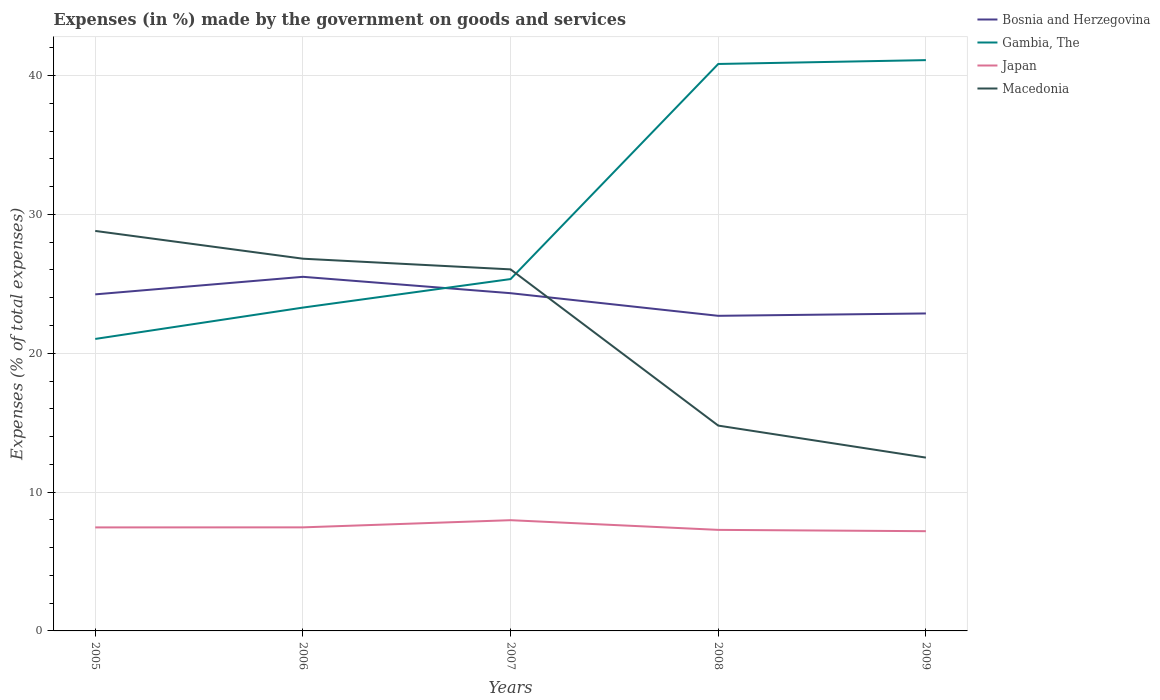Does the line corresponding to Macedonia intersect with the line corresponding to Bosnia and Herzegovina?
Offer a terse response. Yes. Across all years, what is the maximum percentage of expenses made by the government on goods and services in Japan?
Ensure brevity in your answer.  7.18. What is the total percentage of expenses made by the government on goods and services in Bosnia and Herzegovina in the graph?
Offer a very short reply. 1.18. What is the difference between the highest and the second highest percentage of expenses made by the government on goods and services in Japan?
Provide a succinct answer. 0.79. What is the difference between the highest and the lowest percentage of expenses made by the government on goods and services in Macedonia?
Give a very brief answer. 3. Is the percentage of expenses made by the government on goods and services in Japan strictly greater than the percentage of expenses made by the government on goods and services in Macedonia over the years?
Your answer should be very brief. Yes. How many years are there in the graph?
Ensure brevity in your answer.  5. What is the difference between two consecutive major ticks on the Y-axis?
Your answer should be compact. 10. Are the values on the major ticks of Y-axis written in scientific E-notation?
Your answer should be compact. No. Does the graph contain grids?
Provide a succinct answer. Yes. Where does the legend appear in the graph?
Offer a very short reply. Top right. What is the title of the graph?
Provide a succinct answer. Expenses (in %) made by the government on goods and services. Does "Armenia" appear as one of the legend labels in the graph?
Your answer should be very brief. No. What is the label or title of the Y-axis?
Provide a succinct answer. Expenses (% of total expenses). What is the Expenses (% of total expenses) in Bosnia and Herzegovina in 2005?
Offer a terse response. 24.24. What is the Expenses (% of total expenses) of Gambia, The in 2005?
Offer a terse response. 21.03. What is the Expenses (% of total expenses) in Japan in 2005?
Offer a very short reply. 7.46. What is the Expenses (% of total expenses) of Macedonia in 2005?
Offer a terse response. 28.81. What is the Expenses (% of total expenses) in Bosnia and Herzegovina in 2006?
Your response must be concise. 25.5. What is the Expenses (% of total expenses) of Gambia, The in 2006?
Offer a very short reply. 23.29. What is the Expenses (% of total expenses) of Japan in 2006?
Offer a terse response. 7.46. What is the Expenses (% of total expenses) in Macedonia in 2006?
Your response must be concise. 26.81. What is the Expenses (% of total expenses) in Bosnia and Herzegovina in 2007?
Make the answer very short. 24.32. What is the Expenses (% of total expenses) in Gambia, The in 2007?
Your response must be concise. 25.34. What is the Expenses (% of total expenses) of Japan in 2007?
Offer a terse response. 7.98. What is the Expenses (% of total expenses) in Macedonia in 2007?
Give a very brief answer. 26.04. What is the Expenses (% of total expenses) in Bosnia and Herzegovina in 2008?
Offer a very short reply. 22.7. What is the Expenses (% of total expenses) of Gambia, The in 2008?
Provide a short and direct response. 40.83. What is the Expenses (% of total expenses) of Japan in 2008?
Offer a very short reply. 7.28. What is the Expenses (% of total expenses) in Macedonia in 2008?
Your response must be concise. 14.79. What is the Expenses (% of total expenses) of Bosnia and Herzegovina in 2009?
Offer a terse response. 22.87. What is the Expenses (% of total expenses) of Gambia, The in 2009?
Your response must be concise. 41.11. What is the Expenses (% of total expenses) of Japan in 2009?
Your answer should be compact. 7.18. What is the Expenses (% of total expenses) in Macedonia in 2009?
Provide a succinct answer. 12.48. Across all years, what is the maximum Expenses (% of total expenses) in Bosnia and Herzegovina?
Offer a very short reply. 25.5. Across all years, what is the maximum Expenses (% of total expenses) in Gambia, The?
Provide a succinct answer. 41.11. Across all years, what is the maximum Expenses (% of total expenses) in Japan?
Your answer should be very brief. 7.98. Across all years, what is the maximum Expenses (% of total expenses) of Macedonia?
Provide a short and direct response. 28.81. Across all years, what is the minimum Expenses (% of total expenses) of Bosnia and Herzegovina?
Provide a succinct answer. 22.7. Across all years, what is the minimum Expenses (% of total expenses) in Gambia, The?
Provide a short and direct response. 21.03. Across all years, what is the minimum Expenses (% of total expenses) of Japan?
Your answer should be compact. 7.18. Across all years, what is the minimum Expenses (% of total expenses) in Macedonia?
Provide a short and direct response. 12.48. What is the total Expenses (% of total expenses) of Bosnia and Herzegovina in the graph?
Ensure brevity in your answer.  119.63. What is the total Expenses (% of total expenses) in Gambia, The in the graph?
Give a very brief answer. 151.6. What is the total Expenses (% of total expenses) in Japan in the graph?
Your response must be concise. 37.35. What is the total Expenses (% of total expenses) of Macedonia in the graph?
Offer a terse response. 108.93. What is the difference between the Expenses (% of total expenses) in Bosnia and Herzegovina in 2005 and that in 2006?
Offer a very short reply. -1.26. What is the difference between the Expenses (% of total expenses) of Gambia, The in 2005 and that in 2006?
Offer a terse response. -2.26. What is the difference between the Expenses (% of total expenses) in Japan in 2005 and that in 2006?
Offer a very short reply. -0. What is the difference between the Expenses (% of total expenses) of Macedonia in 2005 and that in 2006?
Keep it short and to the point. 2. What is the difference between the Expenses (% of total expenses) of Bosnia and Herzegovina in 2005 and that in 2007?
Your answer should be compact. -0.08. What is the difference between the Expenses (% of total expenses) in Gambia, The in 2005 and that in 2007?
Ensure brevity in your answer.  -4.31. What is the difference between the Expenses (% of total expenses) in Japan in 2005 and that in 2007?
Offer a very short reply. -0.52. What is the difference between the Expenses (% of total expenses) in Macedonia in 2005 and that in 2007?
Offer a terse response. 2.77. What is the difference between the Expenses (% of total expenses) in Bosnia and Herzegovina in 2005 and that in 2008?
Offer a very short reply. 1.54. What is the difference between the Expenses (% of total expenses) in Gambia, The in 2005 and that in 2008?
Offer a very short reply. -19.8. What is the difference between the Expenses (% of total expenses) in Japan in 2005 and that in 2008?
Keep it short and to the point. 0.18. What is the difference between the Expenses (% of total expenses) in Macedonia in 2005 and that in 2008?
Ensure brevity in your answer.  14.02. What is the difference between the Expenses (% of total expenses) in Bosnia and Herzegovina in 2005 and that in 2009?
Give a very brief answer. 1.37. What is the difference between the Expenses (% of total expenses) in Gambia, The in 2005 and that in 2009?
Offer a terse response. -20.08. What is the difference between the Expenses (% of total expenses) of Japan in 2005 and that in 2009?
Keep it short and to the point. 0.27. What is the difference between the Expenses (% of total expenses) of Macedonia in 2005 and that in 2009?
Your answer should be compact. 16.33. What is the difference between the Expenses (% of total expenses) in Bosnia and Herzegovina in 2006 and that in 2007?
Offer a terse response. 1.18. What is the difference between the Expenses (% of total expenses) in Gambia, The in 2006 and that in 2007?
Ensure brevity in your answer.  -2.05. What is the difference between the Expenses (% of total expenses) in Japan in 2006 and that in 2007?
Make the answer very short. -0.52. What is the difference between the Expenses (% of total expenses) in Macedonia in 2006 and that in 2007?
Offer a very short reply. 0.77. What is the difference between the Expenses (% of total expenses) of Bosnia and Herzegovina in 2006 and that in 2008?
Provide a short and direct response. 2.81. What is the difference between the Expenses (% of total expenses) of Gambia, The in 2006 and that in 2008?
Your answer should be very brief. -17.55. What is the difference between the Expenses (% of total expenses) in Japan in 2006 and that in 2008?
Give a very brief answer. 0.18. What is the difference between the Expenses (% of total expenses) of Macedonia in 2006 and that in 2008?
Your answer should be very brief. 12.02. What is the difference between the Expenses (% of total expenses) of Bosnia and Herzegovina in 2006 and that in 2009?
Ensure brevity in your answer.  2.64. What is the difference between the Expenses (% of total expenses) in Gambia, The in 2006 and that in 2009?
Your response must be concise. -17.82. What is the difference between the Expenses (% of total expenses) in Japan in 2006 and that in 2009?
Your answer should be compact. 0.28. What is the difference between the Expenses (% of total expenses) in Macedonia in 2006 and that in 2009?
Provide a succinct answer. 14.33. What is the difference between the Expenses (% of total expenses) in Bosnia and Herzegovina in 2007 and that in 2008?
Your answer should be very brief. 1.63. What is the difference between the Expenses (% of total expenses) in Gambia, The in 2007 and that in 2008?
Provide a succinct answer. -15.49. What is the difference between the Expenses (% of total expenses) in Japan in 2007 and that in 2008?
Provide a succinct answer. 0.7. What is the difference between the Expenses (% of total expenses) in Macedonia in 2007 and that in 2008?
Provide a short and direct response. 11.25. What is the difference between the Expenses (% of total expenses) of Bosnia and Herzegovina in 2007 and that in 2009?
Give a very brief answer. 1.46. What is the difference between the Expenses (% of total expenses) in Gambia, The in 2007 and that in 2009?
Provide a succinct answer. -15.77. What is the difference between the Expenses (% of total expenses) of Japan in 2007 and that in 2009?
Provide a succinct answer. 0.79. What is the difference between the Expenses (% of total expenses) of Macedonia in 2007 and that in 2009?
Provide a short and direct response. 13.56. What is the difference between the Expenses (% of total expenses) in Bosnia and Herzegovina in 2008 and that in 2009?
Your answer should be very brief. -0.17. What is the difference between the Expenses (% of total expenses) of Gambia, The in 2008 and that in 2009?
Keep it short and to the point. -0.28. What is the difference between the Expenses (% of total expenses) of Japan in 2008 and that in 2009?
Provide a succinct answer. 0.09. What is the difference between the Expenses (% of total expenses) of Macedonia in 2008 and that in 2009?
Make the answer very short. 2.31. What is the difference between the Expenses (% of total expenses) of Bosnia and Herzegovina in 2005 and the Expenses (% of total expenses) of Gambia, The in 2006?
Your answer should be compact. 0.95. What is the difference between the Expenses (% of total expenses) of Bosnia and Herzegovina in 2005 and the Expenses (% of total expenses) of Japan in 2006?
Ensure brevity in your answer.  16.78. What is the difference between the Expenses (% of total expenses) of Bosnia and Herzegovina in 2005 and the Expenses (% of total expenses) of Macedonia in 2006?
Give a very brief answer. -2.57. What is the difference between the Expenses (% of total expenses) in Gambia, The in 2005 and the Expenses (% of total expenses) in Japan in 2006?
Give a very brief answer. 13.57. What is the difference between the Expenses (% of total expenses) of Gambia, The in 2005 and the Expenses (% of total expenses) of Macedonia in 2006?
Your answer should be compact. -5.78. What is the difference between the Expenses (% of total expenses) in Japan in 2005 and the Expenses (% of total expenses) in Macedonia in 2006?
Keep it short and to the point. -19.35. What is the difference between the Expenses (% of total expenses) in Bosnia and Herzegovina in 2005 and the Expenses (% of total expenses) in Gambia, The in 2007?
Ensure brevity in your answer.  -1.1. What is the difference between the Expenses (% of total expenses) of Bosnia and Herzegovina in 2005 and the Expenses (% of total expenses) of Japan in 2007?
Your answer should be compact. 16.26. What is the difference between the Expenses (% of total expenses) in Bosnia and Herzegovina in 2005 and the Expenses (% of total expenses) in Macedonia in 2007?
Your answer should be compact. -1.8. What is the difference between the Expenses (% of total expenses) in Gambia, The in 2005 and the Expenses (% of total expenses) in Japan in 2007?
Provide a short and direct response. 13.05. What is the difference between the Expenses (% of total expenses) of Gambia, The in 2005 and the Expenses (% of total expenses) of Macedonia in 2007?
Your answer should be very brief. -5.01. What is the difference between the Expenses (% of total expenses) in Japan in 2005 and the Expenses (% of total expenses) in Macedonia in 2007?
Offer a very short reply. -18.58. What is the difference between the Expenses (% of total expenses) of Bosnia and Herzegovina in 2005 and the Expenses (% of total expenses) of Gambia, The in 2008?
Ensure brevity in your answer.  -16.59. What is the difference between the Expenses (% of total expenses) in Bosnia and Herzegovina in 2005 and the Expenses (% of total expenses) in Japan in 2008?
Give a very brief answer. 16.96. What is the difference between the Expenses (% of total expenses) of Bosnia and Herzegovina in 2005 and the Expenses (% of total expenses) of Macedonia in 2008?
Offer a terse response. 9.45. What is the difference between the Expenses (% of total expenses) of Gambia, The in 2005 and the Expenses (% of total expenses) of Japan in 2008?
Offer a terse response. 13.75. What is the difference between the Expenses (% of total expenses) of Gambia, The in 2005 and the Expenses (% of total expenses) of Macedonia in 2008?
Provide a short and direct response. 6.24. What is the difference between the Expenses (% of total expenses) in Japan in 2005 and the Expenses (% of total expenses) in Macedonia in 2008?
Offer a very short reply. -7.33. What is the difference between the Expenses (% of total expenses) in Bosnia and Herzegovina in 2005 and the Expenses (% of total expenses) in Gambia, The in 2009?
Keep it short and to the point. -16.87. What is the difference between the Expenses (% of total expenses) in Bosnia and Herzegovina in 2005 and the Expenses (% of total expenses) in Japan in 2009?
Offer a very short reply. 17.06. What is the difference between the Expenses (% of total expenses) in Bosnia and Herzegovina in 2005 and the Expenses (% of total expenses) in Macedonia in 2009?
Offer a very short reply. 11.76. What is the difference between the Expenses (% of total expenses) of Gambia, The in 2005 and the Expenses (% of total expenses) of Japan in 2009?
Make the answer very short. 13.85. What is the difference between the Expenses (% of total expenses) in Gambia, The in 2005 and the Expenses (% of total expenses) in Macedonia in 2009?
Your answer should be very brief. 8.55. What is the difference between the Expenses (% of total expenses) of Japan in 2005 and the Expenses (% of total expenses) of Macedonia in 2009?
Offer a very short reply. -5.03. What is the difference between the Expenses (% of total expenses) in Bosnia and Herzegovina in 2006 and the Expenses (% of total expenses) in Gambia, The in 2007?
Your answer should be compact. 0.16. What is the difference between the Expenses (% of total expenses) in Bosnia and Herzegovina in 2006 and the Expenses (% of total expenses) in Japan in 2007?
Ensure brevity in your answer.  17.53. What is the difference between the Expenses (% of total expenses) in Bosnia and Herzegovina in 2006 and the Expenses (% of total expenses) in Macedonia in 2007?
Ensure brevity in your answer.  -0.54. What is the difference between the Expenses (% of total expenses) of Gambia, The in 2006 and the Expenses (% of total expenses) of Japan in 2007?
Keep it short and to the point. 15.31. What is the difference between the Expenses (% of total expenses) in Gambia, The in 2006 and the Expenses (% of total expenses) in Macedonia in 2007?
Your response must be concise. -2.75. What is the difference between the Expenses (% of total expenses) in Japan in 2006 and the Expenses (% of total expenses) in Macedonia in 2007?
Offer a terse response. -18.58. What is the difference between the Expenses (% of total expenses) in Bosnia and Herzegovina in 2006 and the Expenses (% of total expenses) in Gambia, The in 2008?
Offer a terse response. -15.33. What is the difference between the Expenses (% of total expenses) in Bosnia and Herzegovina in 2006 and the Expenses (% of total expenses) in Japan in 2008?
Provide a succinct answer. 18.23. What is the difference between the Expenses (% of total expenses) of Bosnia and Herzegovina in 2006 and the Expenses (% of total expenses) of Macedonia in 2008?
Give a very brief answer. 10.72. What is the difference between the Expenses (% of total expenses) in Gambia, The in 2006 and the Expenses (% of total expenses) in Japan in 2008?
Your answer should be compact. 16.01. What is the difference between the Expenses (% of total expenses) in Gambia, The in 2006 and the Expenses (% of total expenses) in Macedonia in 2008?
Ensure brevity in your answer.  8.5. What is the difference between the Expenses (% of total expenses) of Japan in 2006 and the Expenses (% of total expenses) of Macedonia in 2008?
Make the answer very short. -7.33. What is the difference between the Expenses (% of total expenses) in Bosnia and Herzegovina in 2006 and the Expenses (% of total expenses) in Gambia, The in 2009?
Provide a succinct answer. -15.61. What is the difference between the Expenses (% of total expenses) of Bosnia and Herzegovina in 2006 and the Expenses (% of total expenses) of Japan in 2009?
Provide a succinct answer. 18.32. What is the difference between the Expenses (% of total expenses) of Bosnia and Herzegovina in 2006 and the Expenses (% of total expenses) of Macedonia in 2009?
Provide a succinct answer. 13.02. What is the difference between the Expenses (% of total expenses) of Gambia, The in 2006 and the Expenses (% of total expenses) of Japan in 2009?
Provide a short and direct response. 16.1. What is the difference between the Expenses (% of total expenses) of Gambia, The in 2006 and the Expenses (% of total expenses) of Macedonia in 2009?
Provide a short and direct response. 10.81. What is the difference between the Expenses (% of total expenses) of Japan in 2006 and the Expenses (% of total expenses) of Macedonia in 2009?
Provide a succinct answer. -5.02. What is the difference between the Expenses (% of total expenses) of Bosnia and Herzegovina in 2007 and the Expenses (% of total expenses) of Gambia, The in 2008?
Your response must be concise. -16.51. What is the difference between the Expenses (% of total expenses) of Bosnia and Herzegovina in 2007 and the Expenses (% of total expenses) of Japan in 2008?
Make the answer very short. 17.05. What is the difference between the Expenses (% of total expenses) of Bosnia and Herzegovina in 2007 and the Expenses (% of total expenses) of Macedonia in 2008?
Provide a short and direct response. 9.54. What is the difference between the Expenses (% of total expenses) of Gambia, The in 2007 and the Expenses (% of total expenses) of Japan in 2008?
Provide a succinct answer. 18.06. What is the difference between the Expenses (% of total expenses) of Gambia, The in 2007 and the Expenses (% of total expenses) of Macedonia in 2008?
Provide a short and direct response. 10.55. What is the difference between the Expenses (% of total expenses) in Japan in 2007 and the Expenses (% of total expenses) in Macedonia in 2008?
Keep it short and to the point. -6.81. What is the difference between the Expenses (% of total expenses) in Bosnia and Herzegovina in 2007 and the Expenses (% of total expenses) in Gambia, The in 2009?
Give a very brief answer. -16.79. What is the difference between the Expenses (% of total expenses) of Bosnia and Herzegovina in 2007 and the Expenses (% of total expenses) of Japan in 2009?
Your answer should be very brief. 17.14. What is the difference between the Expenses (% of total expenses) of Bosnia and Herzegovina in 2007 and the Expenses (% of total expenses) of Macedonia in 2009?
Make the answer very short. 11.84. What is the difference between the Expenses (% of total expenses) of Gambia, The in 2007 and the Expenses (% of total expenses) of Japan in 2009?
Offer a terse response. 18.16. What is the difference between the Expenses (% of total expenses) in Gambia, The in 2007 and the Expenses (% of total expenses) in Macedonia in 2009?
Provide a short and direct response. 12.86. What is the difference between the Expenses (% of total expenses) of Japan in 2007 and the Expenses (% of total expenses) of Macedonia in 2009?
Give a very brief answer. -4.51. What is the difference between the Expenses (% of total expenses) in Bosnia and Herzegovina in 2008 and the Expenses (% of total expenses) in Gambia, The in 2009?
Ensure brevity in your answer.  -18.42. What is the difference between the Expenses (% of total expenses) of Bosnia and Herzegovina in 2008 and the Expenses (% of total expenses) of Japan in 2009?
Your answer should be compact. 15.51. What is the difference between the Expenses (% of total expenses) of Bosnia and Herzegovina in 2008 and the Expenses (% of total expenses) of Macedonia in 2009?
Your response must be concise. 10.21. What is the difference between the Expenses (% of total expenses) in Gambia, The in 2008 and the Expenses (% of total expenses) in Japan in 2009?
Give a very brief answer. 33.65. What is the difference between the Expenses (% of total expenses) in Gambia, The in 2008 and the Expenses (% of total expenses) in Macedonia in 2009?
Make the answer very short. 28.35. What is the difference between the Expenses (% of total expenses) in Japan in 2008 and the Expenses (% of total expenses) in Macedonia in 2009?
Your answer should be compact. -5.2. What is the average Expenses (% of total expenses) of Bosnia and Herzegovina per year?
Make the answer very short. 23.93. What is the average Expenses (% of total expenses) of Gambia, The per year?
Offer a terse response. 30.32. What is the average Expenses (% of total expenses) in Japan per year?
Offer a terse response. 7.47. What is the average Expenses (% of total expenses) in Macedonia per year?
Keep it short and to the point. 21.79. In the year 2005, what is the difference between the Expenses (% of total expenses) in Bosnia and Herzegovina and Expenses (% of total expenses) in Gambia, The?
Your answer should be compact. 3.21. In the year 2005, what is the difference between the Expenses (% of total expenses) in Bosnia and Herzegovina and Expenses (% of total expenses) in Japan?
Provide a short and direct response. 16.78. In the year 2005, what is the difference between the Expenses (% of total expenses) in Bosnia and Herzegovina and Expenses (% of total expenses) in Macedonia?
Give a very brief answer. -4.57. In the year 2005, what is the difference between the Expenses (% of total expenses) of Gambia, The and Expenses (% of total expenses) of Japan?
Your response must be concise. 13.57. In the year 2005, what is the difference between the Expenses (% of total expenses) of Gambia, The and Expenses (% of total expenses) of Macedonia?
Make the answer very short. -7.78. In the year 2005, what is the difference between the Expenses (% of total expenses) of Japan and Expenses (% of total expenses) of Macedonia?
Keep it short and to the point. -21.35. In the year 2006, what is the difference between the Expenses (% of total expenses) of Bosnia and Herzegovina and Expenses (% of total expenses) of Gambia, The?
Provide a succinct answer. 2.22. In the year 2006, what is the difference between the Expenses (% of total expenses) in Bosnia and Herzegovina and Expenses (% of total expenses) in Japan?
Keep it short and to the point. 18.04. In the year 2006, what is the difference between the Expenses (% of total expenses) in Bosnia and Herzegovina and Expenses (% of total expenses) in Macedonia?
Ensure brevity in your answer.  -1.3. In the year 2006, what is the difference between the Expenses (% of total expenses) in Gambia, The and Expenses (% of total expenses) in Japan?
Your answer should be very brief. 15.83. In the year 2006, what is the difference between the Expenses (% of total expenses) of Gambia, The and Expenses (% of total expenses) of Macedonia?
Ensure brevity in your answer.  -3.52. In the year 2006, what is the difference between the Expenses (% of total expenses) of Japan and Expenses (% of total expenses) of Macedonia?
Offer a very short reply. -19.35. In the year 2007, what is the difference between the Expenses (% of total expenses) in Bosnia and Herzegovina and Expenses (% of total expenses) in Gambia, The?
Give a very brief answer. -1.02. In the year 2007, what is the difference between the Expenses (% of total expenses) of Bosnia and Herzegovina and Expenses (% of total expenses) of Japan?
Offer a very short reply. 16.35. In the year 2007, what is the difference between the Expenses (% of total expenses) of Bosnia and Herzegovina and Expenses (% of total expenses) of Macedonia?
Provide a short and direct response. -1.72. In the year 2007, what is the difference between the Expenses (% of total expenses) in Gambia, The and Expenses (% of total expenses) in Japan?
Offer a terse response. 17.37. In the year 2007, what is the difference between the Expenses (% of total expenses) of Gambia, The and Expenses (% of total expenses) of Macedonia?
Your answer should be compact. -0.7. In the year 2007, what is the difference between the Expenses (% of total expenses) in Japan and Expenses (% of total expenses) in Macedonia?
Provide a short and direct response. -18.06. In the year 2008, what is the difference between the Expenses (% of total expenses) in Bosnia and Herzegovina and Expenses (% of total expenses) in Gambia, The?
Keep it short and to the point. -18.14. In the year 2008, what is the difference between the Expenses (% of total expenses) of Bosnia and Herzegovina and Expenses (% of total expenses) of Japan?
Provide a short and direct response. 15.42. In the year 2008, what is the difference between the Expenses (% of total expenses) of Bosnia and Herzegovina and Expenses (% of total expenses) of Macedonia?
Provide a short and direct response. 7.91. In the year 2008, what is the difference between the Expenses (% of total expenses) in Gambia, The and Expenses (% of total expenses) in Japan?
Your response must be concise. 33.56. In the year 2008, what is the difference between the Expenses (% of total expenses) of Gambia, The and Expenses (% of total expenses) of Macedonia?
Offer a terse response. 26.04. In the year 2008, what is the difference between the Expenses (% of total expenses) of Japan and Expenses (% of total expenses) of Macedonia?
Ensure brevity in your answer.  -7.51. In the year 2009, what is the difference between the Expenses (% of total expenses) in Bosnia and Herzegovina and Expenses (% of total expenses) in Gambia, The?
Your answer should be compact. -18.25. In the year 2009, what is the difference between the Expenses (% of total expenses) of Bosnia and Herzegovina and Expenses (% of total expenses) of Japan?
Keep it short and to the point. 15.68. In the year 2009, what is the difference between the Expenses (% of total expenses) of Bosnia and Herzegovina and Expenses (% of total expenses) of Macedonia?
Your response must be concise. 10.38. In the year 2009, what is the difference between the Expenses (% of total expenses) of Gambia, The and Expenses (% of total expenses) of Japan?
Your answer should be compact. 33.93. In the year 2009, what is the difference between the Expenses (% of total expenses) of Gambia, The and Expenses (% of total expenses) of Macedonia?
Offer a very short reply. 28.63. In the year 2009, what is the difference between the Expenses (% of total expenses) in Japan and Expenses (% of total expenses) in Macedonia?
Your response must be concise. -5.3. What is the ratio of the Expenses (% of total expenses) of Bosnia and Herzegovina in 2005 to that in 2006?
Ensure brevity in your answer.  0.95. What is the ratio of the Expenses (% of total expenses) in Gambia, The in 2005 to that in 2006?
Give a very brief answer. 0.9. What is the ratio of the Expenses (% of total expenses) of Japan in 2005 to that in 2006?
Keep it short and to the point. 1. What is the ratio of the Expenses (% of total expenses) of Macedonia in 2005 to that in 2006?
Keep it short and to the point. 1.07. What is the ratio of the Expenses (% of total expenses) in Gambia, The in 2005 to that in 2007?
Make the answer very short. 0.83. What is the ratio of the Expenses (% of total expenses) of Japan in 2005 to that in 2007?
Ensure brevity in your answer.  0.93. What is the ratio of the Expenses (% of total expenses) of Macedonia in 2005 to that in 2007?
Offer a very short reply. 1.11. What is the ratio of the Expenses (% of total expenses) in Bosnia and Herzegovina in 2005 to that in 2008?
Your answer should be very brief. 1.07. What is the ratio of the Expenses (% of total expenses) in Gambia, The in 2005 to that in 2008?
Ensure brevity in your answer.  0.52. What is the ratio of the Expenses (% of total expenses) of Japan in 2005 to that in 2008?
Your response must be concise. 1.02. What is the ratio of the Expenses (% of total expenses) of Macedonia in 2005 to that in 2008?
Offer a very short reply. 1.95. What is the ratio of the Expenses (% of total expenses) of Bosnia and Herzegovina in 2005 to that in 2009?
Offer a very short reply. 1.06. What is the ratio of the Expenses (% of total expenses) in Gambia, The in 2005 to that in 2009?
Provide a short and direct response. 0.51. What is the ratio of the Expenses (% of total expenses) in Japan in 2005 to that in 2009?
Provide a short and direct response. 1.04. What is the ratio of the Expenses (% of total expenses) in Macedonia in 2005 to that in 2009?
Give a very brief answer. 2.31. What is the ratio of the Expenses (% of total expenses) in Bosnia and Herzegovina in 2006 to that in 2007?
Give a very brief answer. 1.05. What is the ratio of the Expenses (% of total expenses) of Gambia, The in 2006 to that in 2007?
Offer a terse response. 0.92. What is the ratio of the Expenses (% of total expenses) in Japan in 2006 to that in 2007?
Keep it short and to the point. 0.94. What is the ratio of the Expenses (% of total expenses) of Macedonia in 2006 to that in 2007?
Keep it short and to the point. 1.03. What is the ratio of the Expenses (% of total expenses) in Bosnia and Herzegovina in 2006 to that in 2008?
Offer a very short reply. 1.12. What is the ratio of the Expenses (% of total expenses) in Gambia, The in 2006 to that in 2008?
Make the answer very short. 0.57. What is the ratio of the Expenses (% of total expenses) of Japan in 2006 to that in 2008?
Give a very brief answer. 1.02. What is the ratio of the Expenses (% of total expenses) in Macedonia in 2006 to that in 2008?
Make the answer very short. 1.81. What is the ratio of the Expenses (% of total expenses) in Bosnia and Herzegovina in 2006 to that in 2009?
Your answer should be very brief. 1.12. What is the ratio of the Expenses (% of total expenses) in Gambia, The in 2006 to that in 2009?
Offer a terse response. 0.57. What is the ratio of the Expenses (% of total expenses) in Japan in 2006 to that in 2009?
Your response must be concise. 1.04. What is the ratio of the Expenses (% of total expenses) of Macedonia in 2006 to that in 2009?
Give a very brief answer. 2.15. What is the ratio of the Expenses (% of total expenses) in Bosnia and Herzegovina in 2007 to that in 2008?
Your response must be concise. 1.07. What is the ratio of the Expenses (% of total expenses) of Gambia, The in 2007 to that in 2008?
Offer a terse response. 0.62. What is the ratio of the Expenses (% of total expenses) in Japan in 2007 to that in 2008?
Make the answer very short. 1.1. What is the ratio of the Expenses (% of total expenses) in Macedonia in 2007 to that in 2008?
Make the answer very short. 1.76. What is the ratio of the Expenses (% of total expenses) in Bosnia and Herzegovina in 2007 to that in 2009?
Make the answer very short. 1.06. What is the ratio of the Expenses (% of total expenses) in Gambia, The in 2007 to that in 2009?
Ensure brevity in your answer.  0.62. What is the ratio of the Expenses (% of total expenses) in Japan in 2007 to that in 2009?
Give a very brief answer. 1.11. What is the ratio of the Expenses (% of total expenses) in Macedonia in 2007 to that in 2009?
Give a very brief answer. 2.09. What is the ratio of the Expenses (% of total expenses) in Gambia, The in 2008 to that in 2009?
Provide a succinct answer. 0.99. What is the ratio of the Expenses (% of total expenses) in Japan in 2008 to that in 2009?
Provide a succinct answer. 1.01. What is the ratio of the Expenses (% of total expenses) of Macedonia in 2008 to that in 2009?
Provide a succinct answer. 1.18. What is the difference between the highest and the second highest Expenses (% of total expenses) of Bosnia and Herzegovina?
Ensure brevity in your answer.  1.18. What is the difference between the highest and the second highest Expenses (% of total expenses) in Gambia, The?
Provide a succinct answer. 0.28. What is the difference between the highest and the second highest Expenses (% of total expenses) of Japan?
Make the answer very short. 0.52. What is the difference between the highest and the second highest Expenses (% of total expenses) in Macedonia?
Your answer should be very brief. 2. What is the difference between the highest and the lowest Expenses (% of total expenses) of Bosnia and Herzegovina?
Make the answer very short. 2.81. What is the difference between the highest and the lowest Expenses (% of total expenses) of Gambia, The?
Your answer should be very brief. 20.08. What is the difference between the highest and the lowest Expenses (% of total expenses) in Japan?
Your response must be concise. 0.79. What is the difference between the highest and the lowest Expenses (% of total expenses) of Macedonia?
Offer a very short reply. 16.33. 